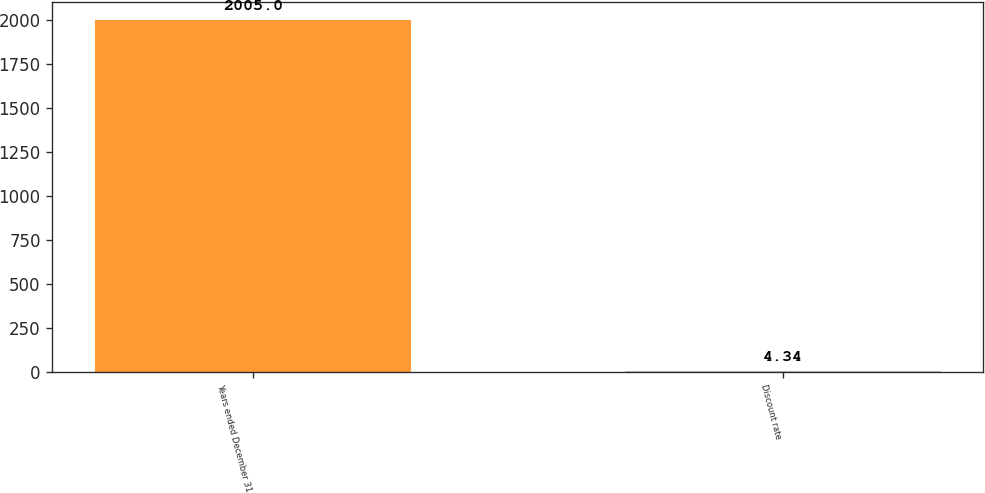Convert chart. <chart><loc_0><loc_0><loc_500><loc_500><bar_chart><fcel>Years ended December 31<fcel>Discount rate<nl><fcel>2005<fcel>4.34<nl></chart> 